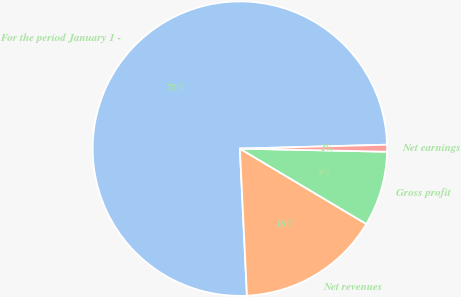Convert chart to OTSL. <chart><loc_0><loc_0><loc_500><loc_500><pie_chart><fcel>For the period January 1 -<fcel>Net revenues<fcel>Gross profit<fcel>Net earnings<nl><fcel>75.35%<fcel>15.68%<fcel>8.22%<fcel>0.76%<nl></chart> 